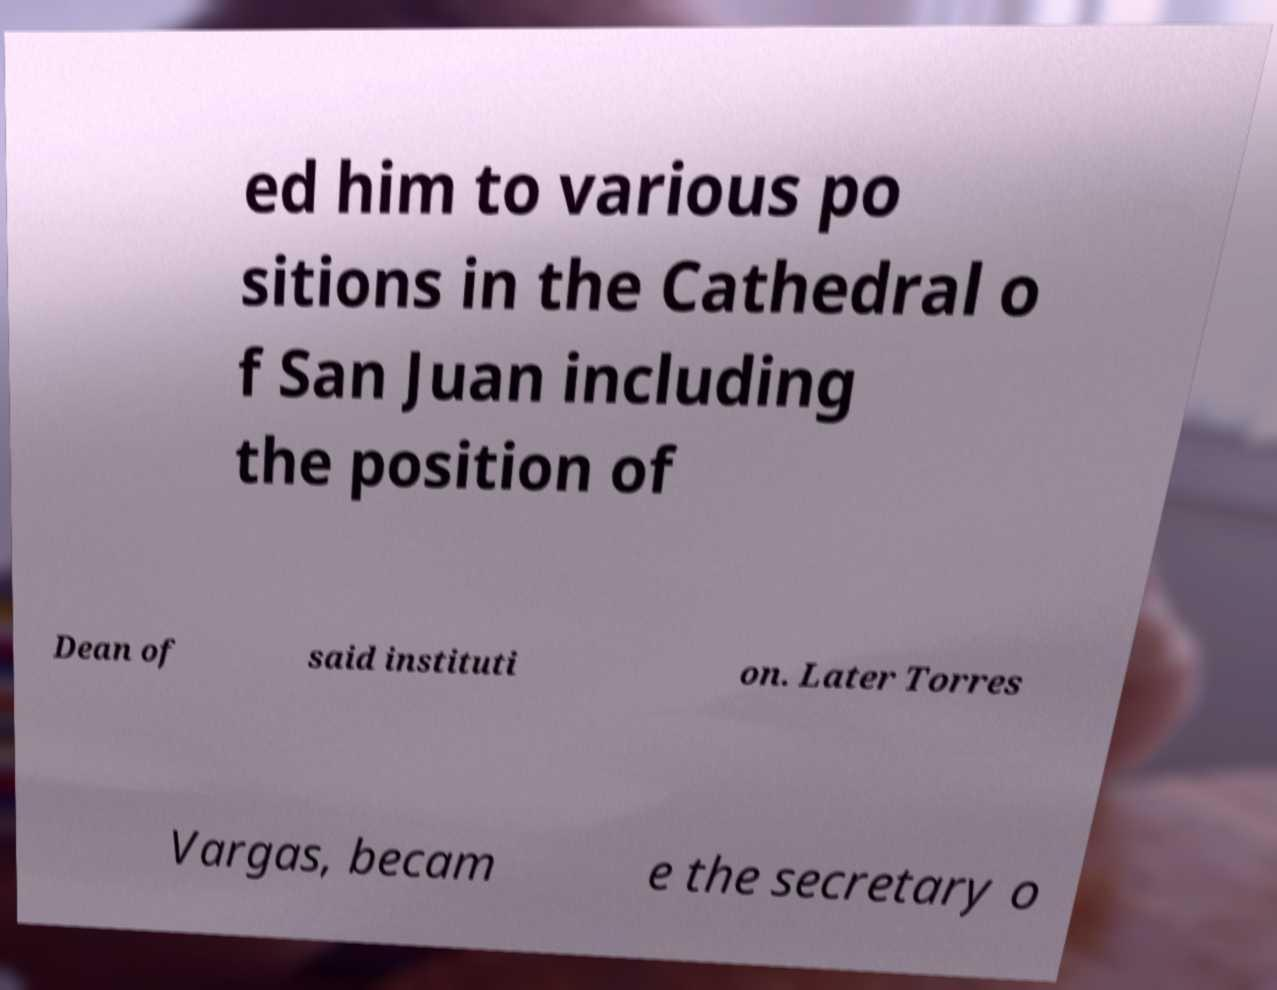Could you assist in decoding the text presented in this image and type it out clearly? ed him to various po sitions in the Cathedral o f San Juan including the position of Dean of said instituti on. Later Torres Vargas, becam e the secretary o 